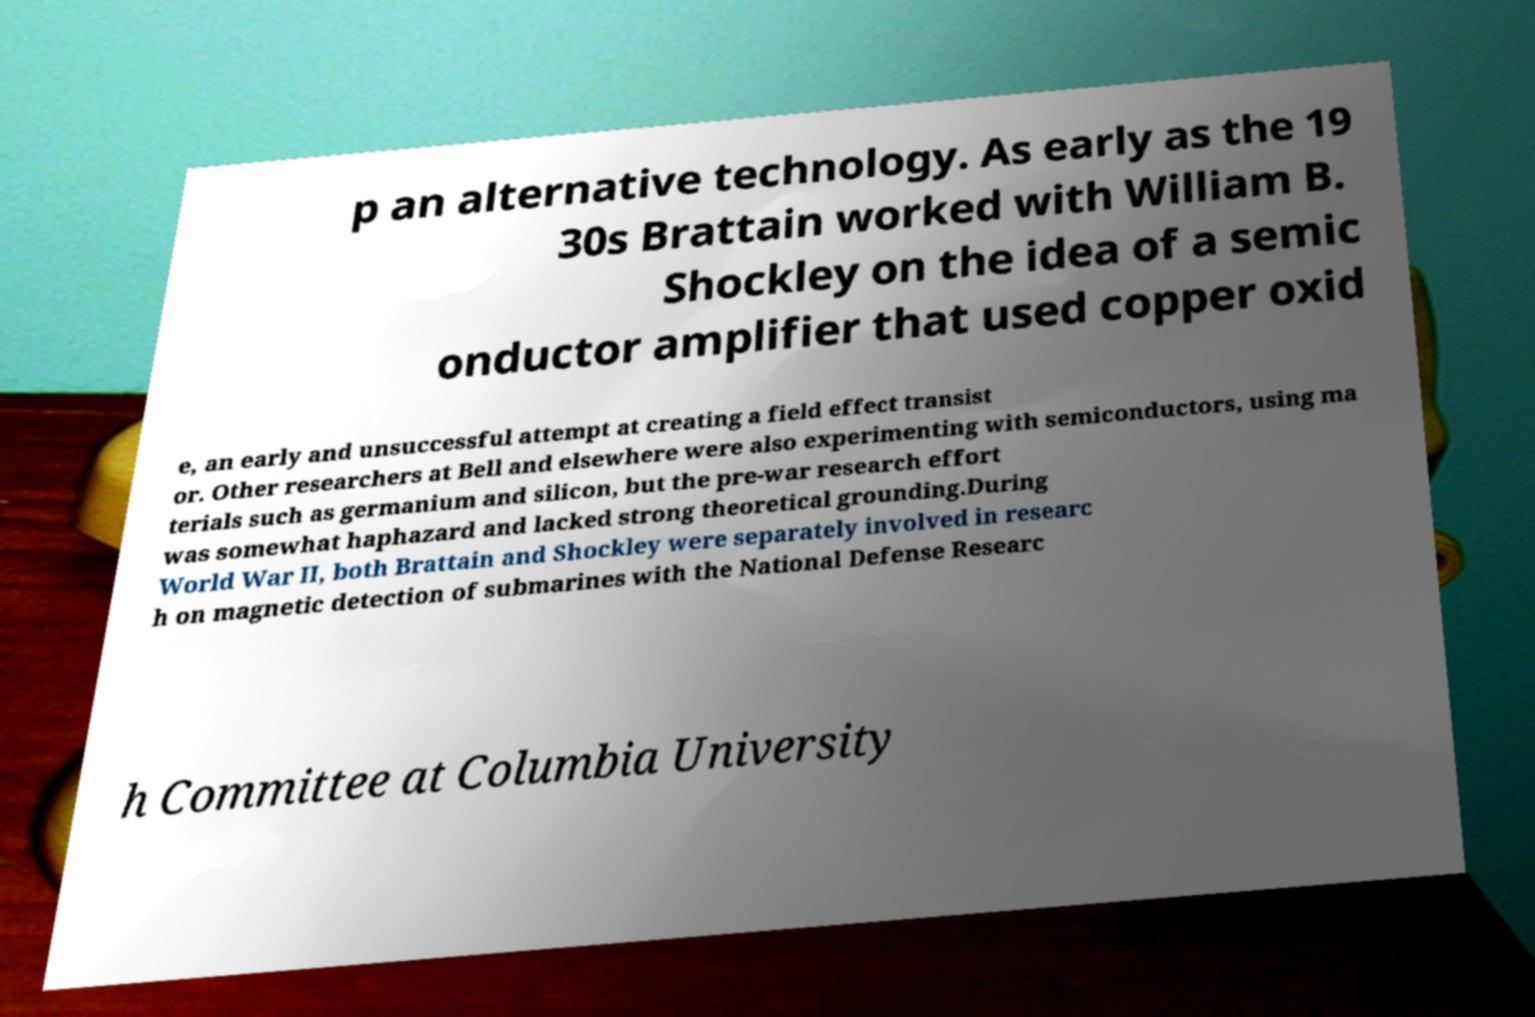Can you read and provide the text displayed in the image?This photo seems to have some interesting text. Can you extract and type it out for me? p an alternative technology. As early as the 19 30s Brattain worked with William B. Shockley on the idea of a semic onductor amplifier that used copper oxid e, an early and unsuccessful attempt at creating a field effect transist or. Other researchers at Bell and elsewhere were also experimenting with semiconductors, using ma terials such as germanium and silicon, but the pre-war research effort was somewhat haphazard and lacked strong theoretical grounding.During World War II, both Brattain and Shockley were separately involved in researc h on magnetic detection of submarines with the National Defense Researc h Committee at Columbia University 